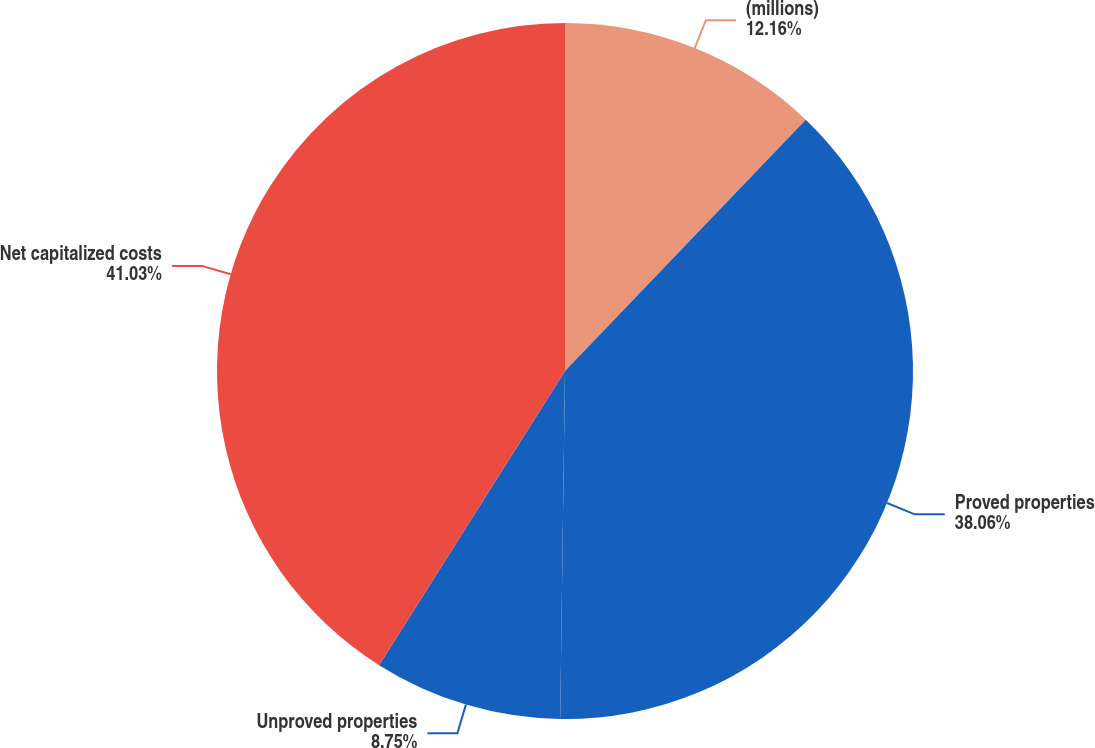Convert chart to OTSL. <chart><loc_0><loc_0><loc_500><loc_500><pie_chart><fcel>(millions)<fcel>Proved properties<fcel>Unproved properties<fcel>Net capitalized costs<nl><fcel>12.16%<fcel>38.06%<fcel>8.75%<fcel>41.03%<nl></chart> 